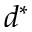<formula> <loc_0><loc_0><loc_500><loc_500>d ^ { * }</formula> 